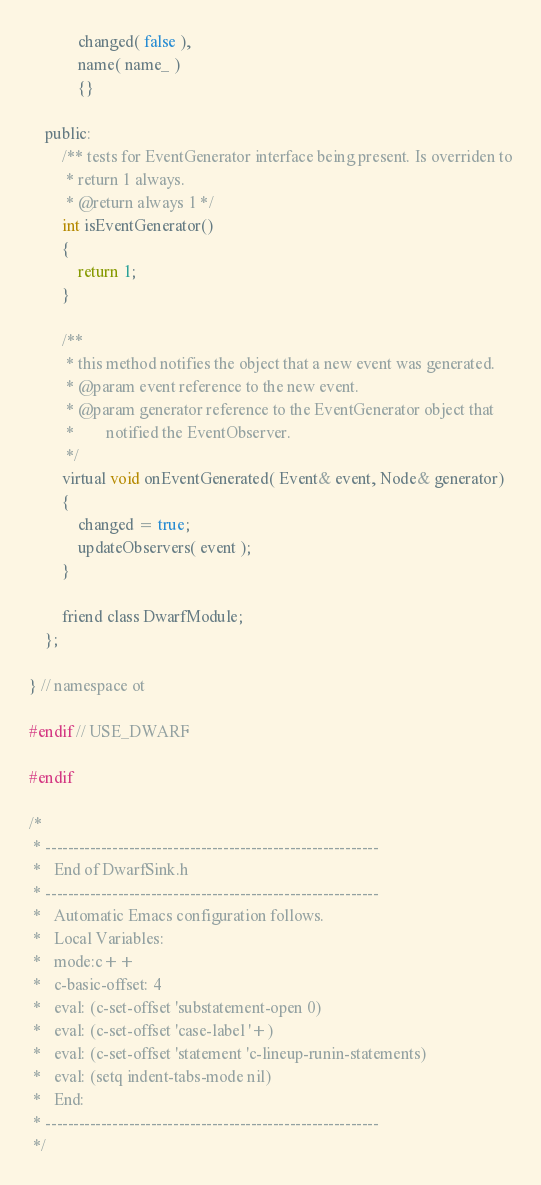Convert code to text. <code><loc_0><loc_0><loc_500><loc_500><_C_>            changed( false ),
            name( name_ )
            {}

    public:
        /** tests for EventGenerator interface being present. Is overriden to
         * return 1 always.
         * @return always 1 */
        int isEventGenerator()
        {
            return 1;
        }

        /**
         * this method notifies the object that a new event was generated.
         * @param event reference to the new event.
         * @param generator reference to the EventGenerator object that
         *        notified the EventObserver.
         */
        virtual void onEventGenerated( Event& event, Node& generator)
        {
            changed = true;
            updateObservers( event );
        }

        friend class DwarfModule;
    };

} // namespace ot

#endif // USE_DWARF

#endif

/* 
 * ------------------------------------------------------------
 *   End of DwarfSink.h
 * ------------------------------------------------------------
 *   Automatic Emacs configuration follows.
 *   Local Variables:
 *   mode:c++
 *   c-basic-offset: 4
 *   eval: (c-set-offset 'substatement-open 0)
 *   eval: (c-set-offset 'case-label '+)
 *   eval: (c-set-offset 'statement 'c-lineup-runin-statements)
 *   eval: (setq indent-tabs-mode nil)
 *   End:
 * ------------------------------------------------------------ 
 */
</code> 